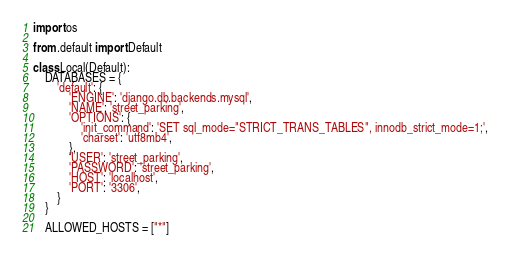<code> <loc_0><loc_0><loc_500><loc_500><_Python_>import os

from .default import Default

class Local(Default):
    DATABASES = {
        'default': {
            'ENGINE': 'django.db.backends.mysql',
            'NAME': 'street_parking',
            'OPTIONS': {
                'init_command': 'SET sql_mode="STRICT_TRANS_TABLES", innodb_strict_mode=1;',
                'charset': 'utf8mb4',
            },
            'USER': 'street_parking',
            'PASSWORD': 'street_parking',
            'HOST': 'localhost',
            'PORT': '3306',
        }
    }

    ALLOWED_HOSTS = ["*"]</code> 